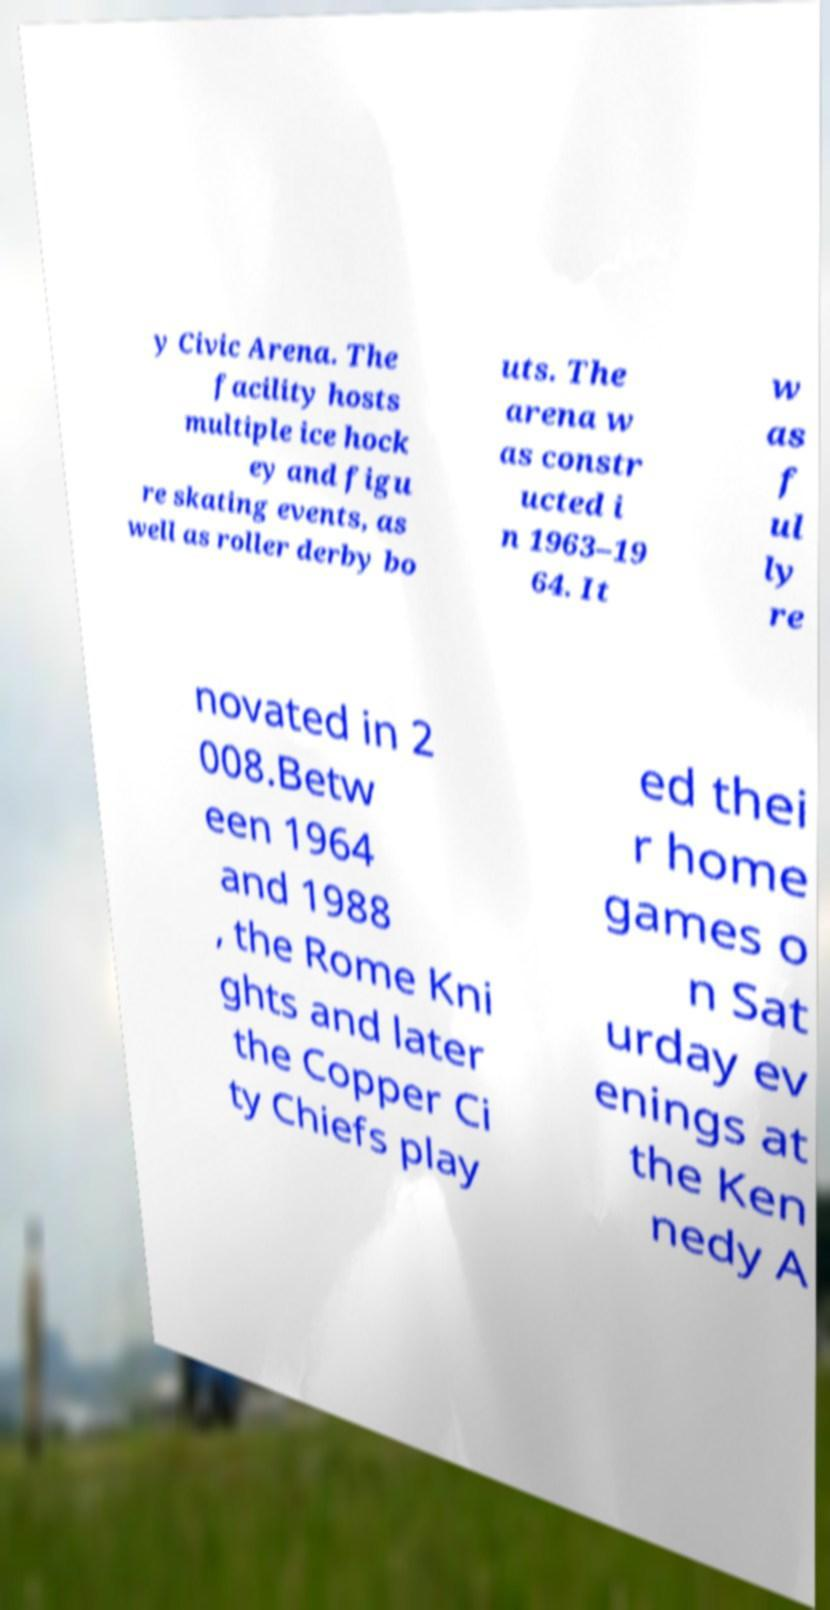I need the written content from this picture converted into text. Can you do that? y Civic Arena. The facility hosts multiple ice hock ey and figu re skating events, as well as roller derby bo uts. The arena w as constr ucted i n 1963–19 64. It w as f ul ly re novated in 2 008.Betw een 1964 and 1988 , the Rome Kni ghts and later the Copper Ci ty Chiefs play ed thei r home games o n Sat urday ev enings at the Ken nedy A 